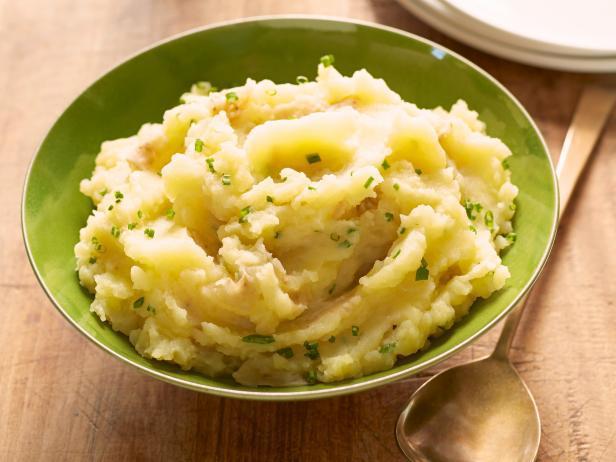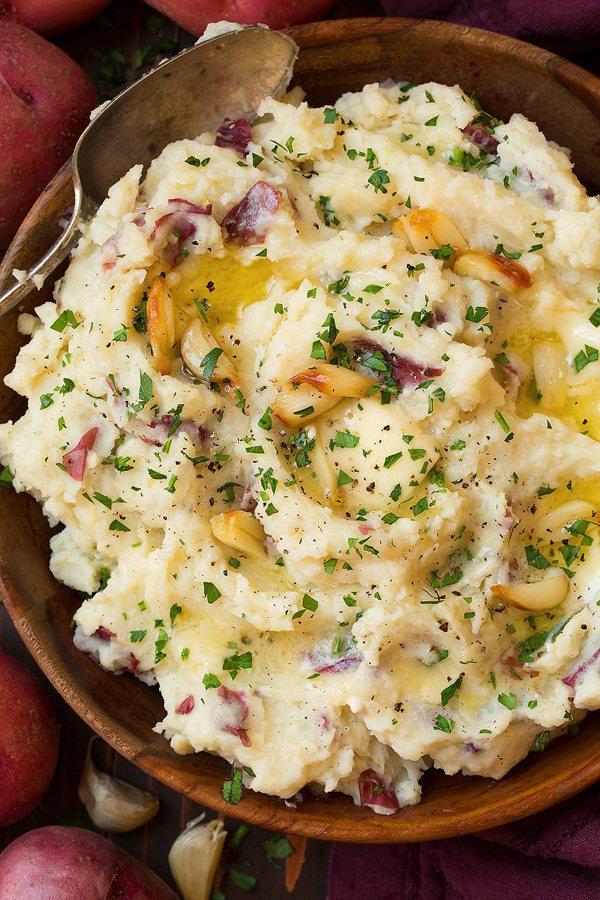The first image is the image on the left, the second image is the image on the right. Analyze the images presented: Is the assertion "An image shows mashed potatoes garnished with chives and served in an olive-green bowl." valid? Answer yes or no. Yes. The first image is the image on the left, the second image is the image on the right. For the images displayed, is the sentence "The food in the image on the right  is in a green bowl." factually correct? Answer yes or no. No. 